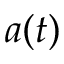<formula> <loc_0><loc_0><loc_500><loc_500>a ( t )</formula> 